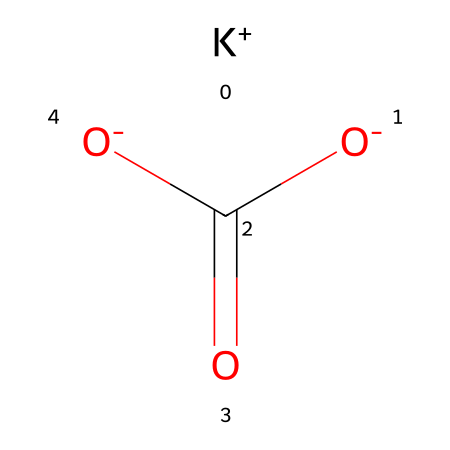What is the molecular formula of potassium bicarbonate? The SMILES notation indicates the presence of one potassium ion (K+), one carbon atom (C), three oxygen atoms (O), and one hydrogen atom (H), which corresponds to the molecular formula KHCO3.
Answer: KHCO3 How many oxygen atoms are present in potassium bicarbonate? By analyzing the SMILES representation, it's clear that there are three oxygen atoms indicated by three occurrences of "O" in the structure.
Answer: 3 What type of ion is present in potassium bicarbonate? The presence of "K+" in the SMILES structure indicates a potassium cation, which confirms that potassium bicarbonate contains a cationic component.
Answer: cation How many acidic hydrogen atoms does potassium bicarbonate have? The structure shows one acidic hydrogen atom (H) bonded to one of the oxygen atoms in the bicarbonate functional group, indicating that it has one acidic hydrogen.
Answer: 1 What determines the effervescence in potassium bicarbonate? Effervescence is primarily caused by the release of carbon dioxide gas (CO2) when potassium bicarbonate reacts with an acid. The bicarbonate part of the molecule contains the bicarbonate ion (HCO3-) that can produce CO2 when it undergoes acid-base reaction.
Answer: CO2 Is potassium bicarbonate considered a strong or weak electrolyte? Potassium bicarbonate is categorized as a weak electrolyte because it does not completely dissociate into its ions in an aqueous solution, which restricts its conductivity compared to strong electrolytes.
Answer: weak What functional group is indicated by "C(=O)[O-]" in potassium bicarbonate? The structure "C(=O)[O-]" describes a carboxylate group, which is characteristic of acids; in this case, it forms part of the bicarbonate structure.
Answer: carboxylate 